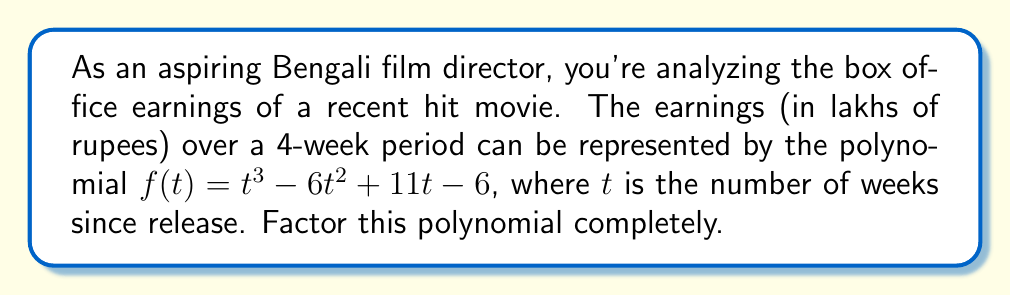Can you solve this math problem? Let's approach this step-by-step:

1) First, we'll check if there are any rational roots using the rational root theorem. The possible rational roots are the factors of the constant term: ±1, ±2, ±3, ±6.

2) Testing these values, we find that $f(1) = 0$. So $(t-1)$ is a factor.

3) We can use polynomial long division to divide $f(t)$ by $(t-1)$:

   $$t^3 - 6t^2 + 11t - 6 = (t-1)(t^2 - 5t + 6)$$

4) Now we need to factor the quadratic $t^2 - 5t + 6$. We can do this by finding two numbers that multiply to give 6 and add to give -5.

5) These numbers are -2 and -3.

6) Therefore, $t^2 - 5t + 6 = (t-2)(t-3)$

7) Combining all factors, we get:

   $$f(t) = (t-1)(t-2)(t-3)$$

This factorization shows that the earnings hit zero (or break-even) at 1, 2, and 3 weeks after release, which could be interesting points for analysis in your film studies.
Answer: $(t-1)(t-2)(t-3)$ 